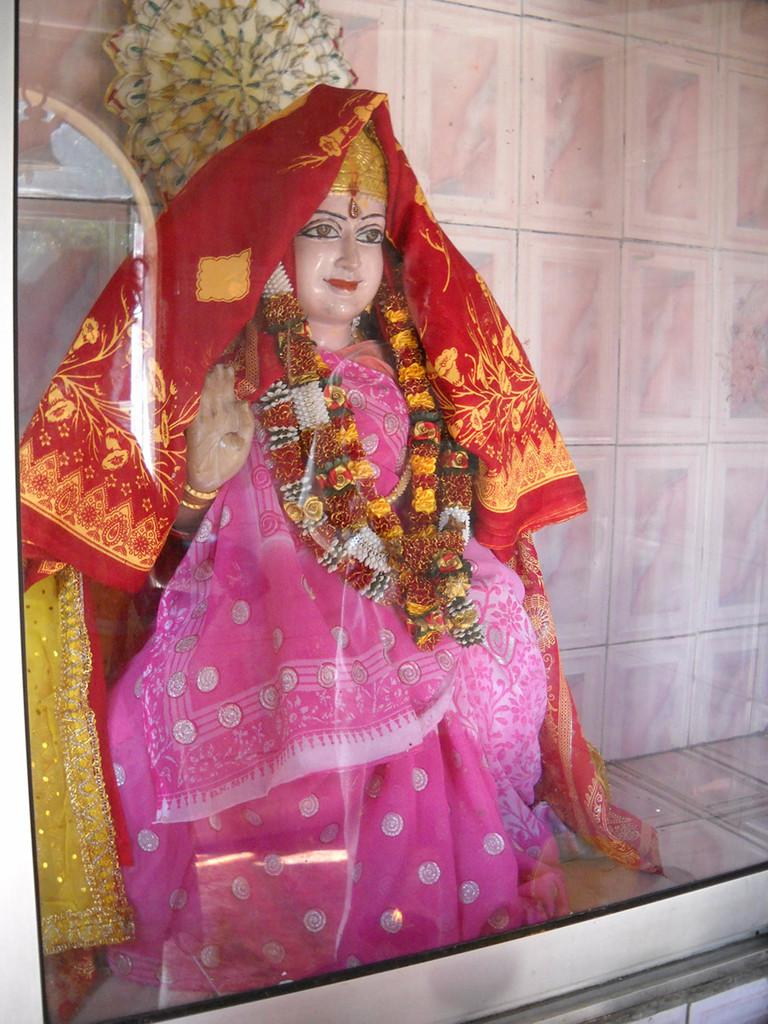What is the main subject of the image? The main subject of the image is an idol of a goddess. How many snails can be seen crawling on the idol in the image? There are no snails present in the image, and therefore no such activity can be observed. 